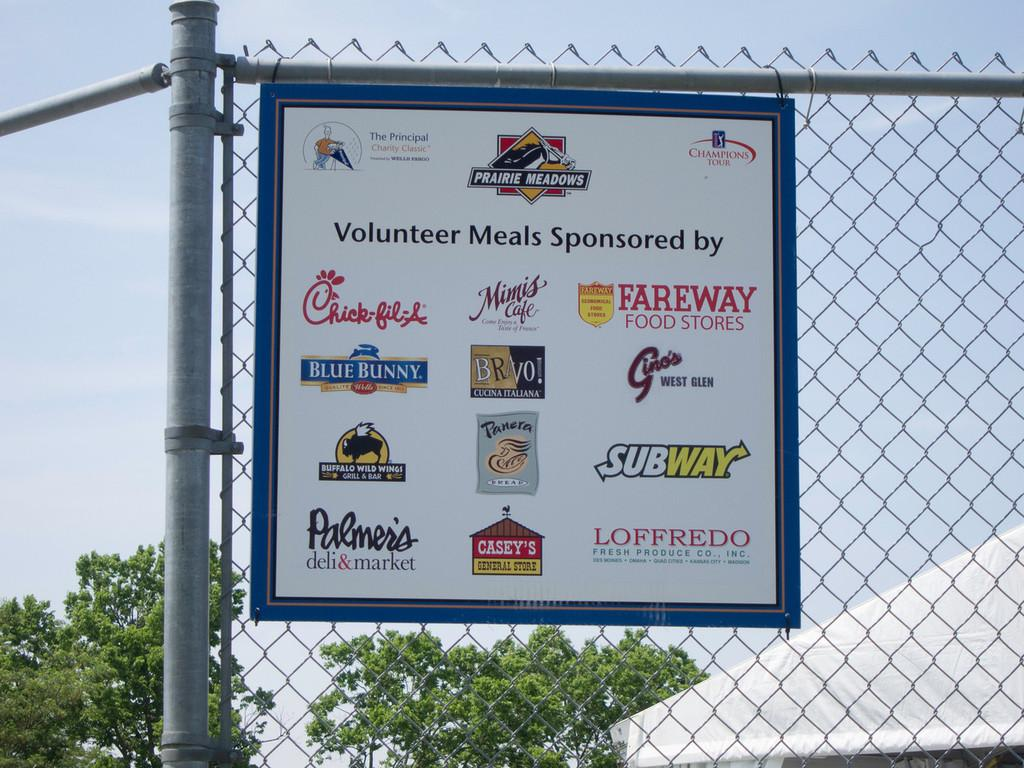Provide a one-sentence caption for the provided image. A sign hanging on a fence shows sponsors of volunteer meals for an event. 